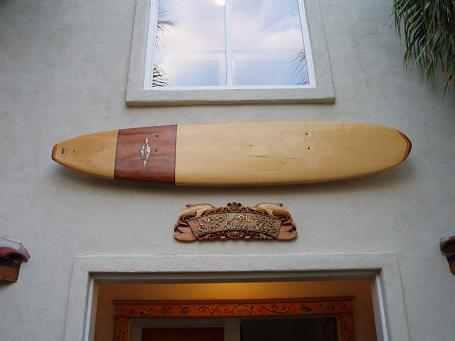Question: what color is the surfboard?
Choices:
A. Brown and tan.
B. Green and yellow.
C. Black and blue.
D. White and brown.
Answer with the letter. Answer: A Question: what animal is on the sign above the doorway?
Choices:
A. A bull.
B. Dolphins.
C. Wolves.
D. A rooster.
Answer with the letter. Answer: B Question: what is above the surfboard?
Choices:
A. A man.
B. A window.
C. A woman.
D. A child.
Answer with the letter. Answer: B 